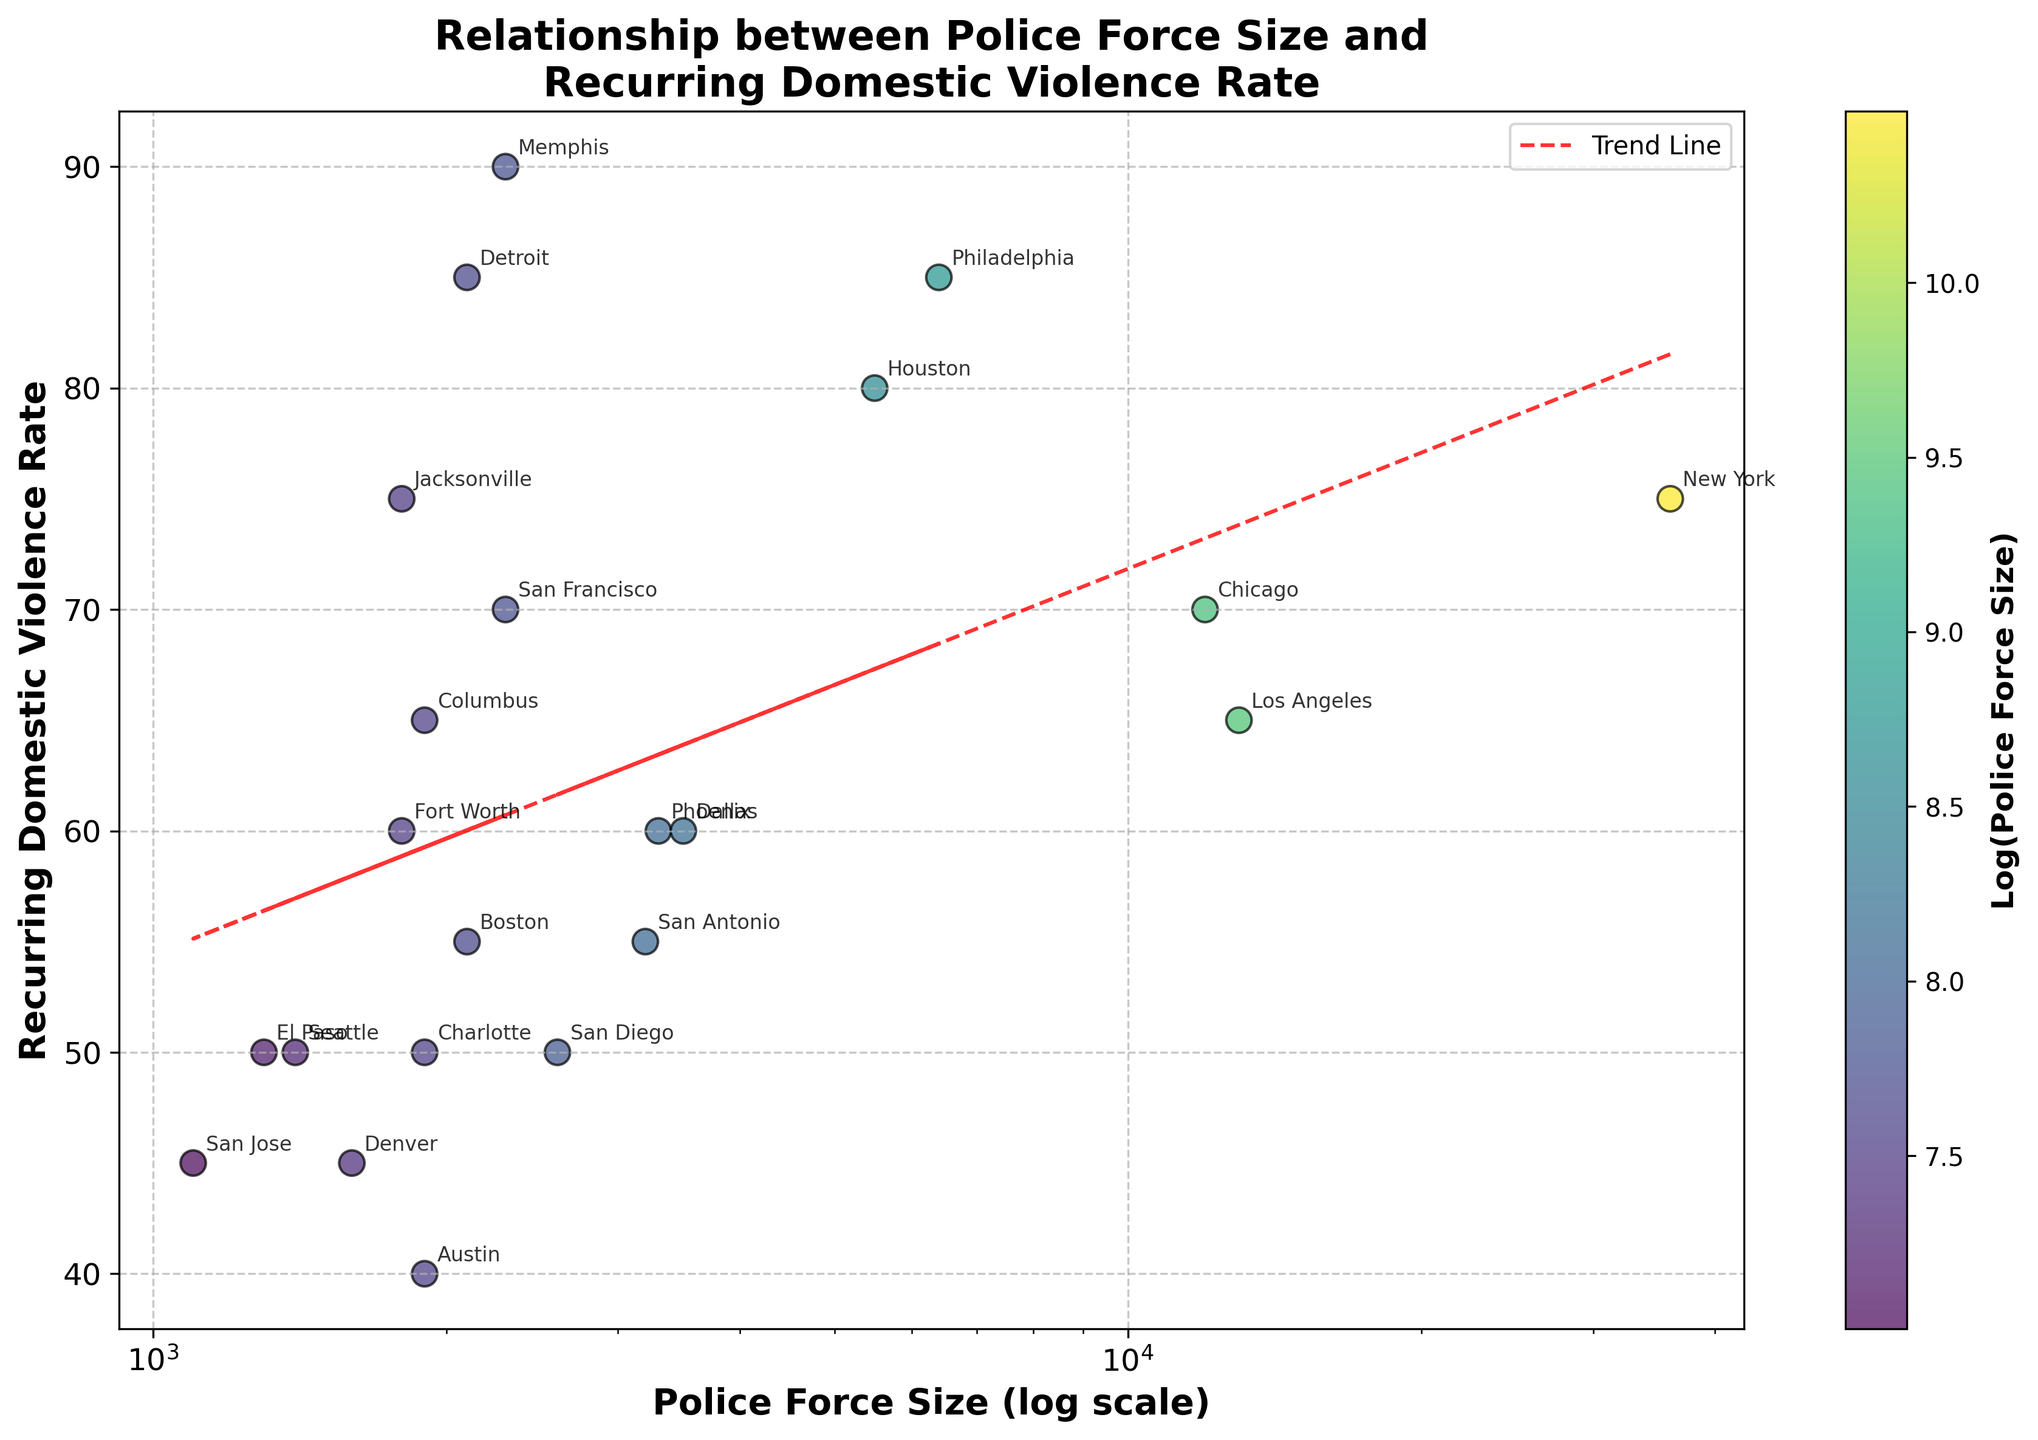What is the title of the scatter plot? The title of the plot is positioned at the top and reads "Relationship between Police Force Size and Recurring Domestic Violence Rate".
Answer: Relationship between Police Force Size and Recurring Domestic Violence Rate Which city has the highest recurring domestic violence rate? By examining the y-axis which represents the recurring domestic violence rate, Memphis has the highest value at 90.
Answer: Memphis How does the size of the police force in Los Angeles compare to that in San Francisco? Los Angeles has a police force size of 13,000, and San Francisco has a force size of 2,300. Therefore, Los Angeles has a much larger police force.
Answer: Los Angeles has a larger police force Which city has the smallest police force size and what is their recurring domestic violence rate? By looking at the x-axis, we can identify San Jose as the city with the smallest police force size of 1,100. The corresponding y-axis value for recurring domestic violence rate is 45.
Answer: San Jose with a rate of 45 Are there any cities with identical recurring domestic violence rates? By observing the y-axis values, we can see that both New York and Jacksonville have a recurring domestic violence rate of 75.
Answer: New York and Jacksonville Which city has the lowest recurring domestic violence rate? The city with the lowest y-axis value for recurring domestic violence rate is Austin, with a rate of 40.
Answer: Austin What is the trend indicated by the "Trend Line"? The trend line is red and dashed, indicating a linear relationship with a negative slope. This infers that as the size of the police force increases, the recurring domestic violence rate tends to decrease.
Answer: As police force size increases, violence rate tends to decrease What does the color of the scatter points indicate? The color of the scatter points varies from light to dark based on the log of the police force size. The color bar on the right indicates this relationship.
Answer: Log(Police Force Size) Which city has a police force size around 3,500 and what is their violence rate? By checking the x-axis for a value of approximately 3,500, the cities are Phoenix and Dallas. Both have a recurring domestic violence rate of 60.
Answer: Phoenix and Dallas with a rate of 60 